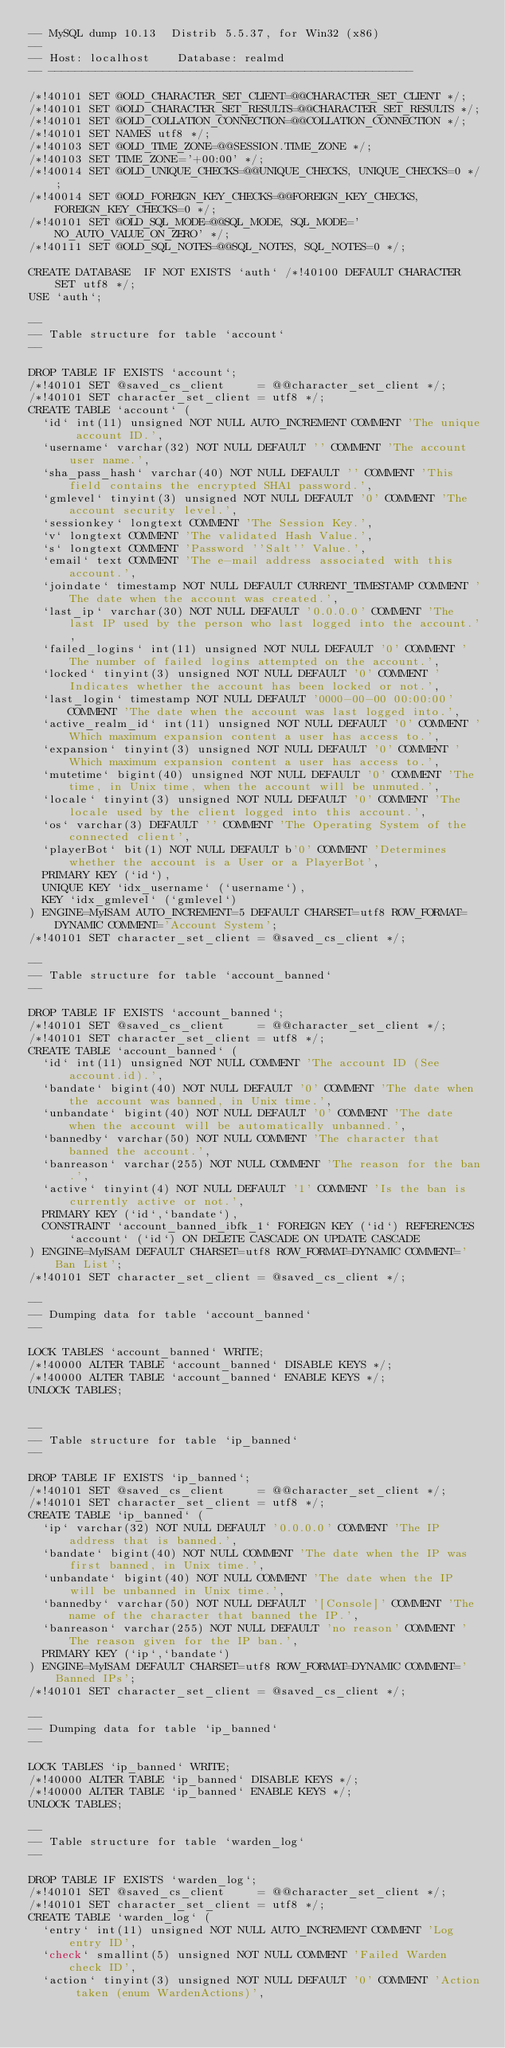<code> <loc_0><loc_0><loc_500><loc_500><_SQL_>-- MySQL dump 10.13  Distrib 5.5.37, for Win32 (x86)
--
-- Host: localhost    Database: realmd
-- ------------------------------------------------------

/*!40101 SET @OLD_CHARACTER_SET_CLIENT=@@CHARACTER_SET_CLIENT */;
/*!40101 SET @OLD_CHARACTER_SET_RESULTS=@@CHARACTER_SET_RESULTS */;
/*!40101 SET @OLD_COLLATION_CONNECTION=@@COLLATION_CONNECTION */;
/*!40101 SET NAMES utf8 */;
/*!40103 SET @OLD_TIME_ZONE=@@SESSION.TIME_ZONE */;
/*!40103 SET TIME_ZONE='+00:00' */;
/*!40014 SET @OLD_UNIQUE_CHECKS=@@UNIQUE_CHECKS, UNIQUE_CHECKS=0 */;
/*!40014 SET @OLD_FOREIGN_KEY_CHECKS=@@FOREIGN_KEY_CHECKS, FOREIGN_KEY_CHECKS=0 */;
/*!40101 SET @OLD_SQL_MODE=@@SQL_MODE, SQL_MODE='NO_AUTO_VALUE_ON_ZERO' */;
/*!40111 SET @OLD_SQL_NOTES=@@SQL_NOTES, SQL_NOTES=0 */;

CREATE DATABASE  IF NOT EXISTS `auth` /*!40100 DEFAULT CHARACTER SET utf8 */;
USE `auth`;

--
-- Table structure for table `account`
--

DROP TABLE IF EXISTS `account`;
/*!40101 SET @saved_cs_client     = @@character_set_client */;
/*!40101 SET character_set_client = utf8 */;
CREATE TABLE `account` (
  `id` int(11) unsigned NOT NULL AUTO_INCREMENT COMMENT 'The unique account ID.',
  `username` varchar(32) NOT NULL DEFAULT '' COMMENT 'The account user name.',
  `sha_pass_hash` varchar(40) NOT NULL DEFAULT '' COMMENT 'This field contains the encrypted SHA1 password.',
  `gmlevel` tinyint(3) unsigned NOT NULL DEFAULT '0' COMMENT 'The account security level.',
  `sessionkey` longtext COMMENT 'The Session Key.',
  `v` longtext COMMENT 'The validated Hash Value.',
  `s` longtext COMMENT 'Password ''Salt'' Value.',
  `email` text COMMENT 'The e-mail address associated with this account.',
  `joindate` timestamp NOT NULL DEFAULT CURRENT_TIMESTAMP COMMENT 'The date when the account was created.',
  `last_ip` varchar(30) NOT NULL DEFAULT '0.0.0.0' COMMENT 'The last IP used by the person who last logged into the account.',
  `failed_logins` int(11) unsigned NOT NULL DEFAULT '0' COMMENT 'The number of failed logins attempted on the account.',
  `locked` tinyint(3) unsigned NOT NULL DEFAULT '0' COMMENT 'Indicates whether the account has been locked or not.',
  `last_login` timestamp NOT NULL DEFAULT '0000-00-00 00:00:00' COMMENT 'The date when the account was last logged into.',
  `active_realm_id` int(11) unsigned NOT NULL DEFAULT '0' COMMENT 'Which maximum expansion content a user has access to.',
  `expansion` tinyint(3) unsigned NOT NULL DEFAULT '0' COMMENT 'Which maximum expansion content a user has access to.',
  `mutetime` bigint(40) unsigned NOT NULL DEFAULT '0' COMMENT 'The time, in Unix time, when the account will be unmuted.',
  `locale` tinyint(3) unsigned NOT NULL DEFAULT '0' COMMENT 'The locale used by the client logged into this account.',
  `os` varchar(3) DEFAULT '' COMMENT 'The Operating System of the connected client',
  `playerBot` bit(1) NOT NULL DEFAULT b'0' COMMENT 'Determines whether the account is a User or a PlayerBot',
  PRIMARY KEY (`id`),
  UNIQUE KEY `idx_username` (`username`),
  KEY `idx_gmlevel` (`gmlevel`)
) ENGINE=MyISAM AUTO_INCREMENT=5 DEFAULT CHARSET=utf8 ROW_FORMAT=DYNAMIC COMMENT='Account System';
/*!40101 SET character_set_client = @saved_cs_client */;

--
-- Table structure for table `account_banned`
--

DROP TABLE IF EXISTS `account_banned`;
/*!40101 SET @saved_cs_client     = @@character_set_client */;
/*!40101 SET character_set_client = utf8 */;
CREATE TABLE `account_banned` (
  `id` int(11) unsigned NOT NULL COMMENT 'The account ID (See account.id).',
  `bandate` bigint(40) NOT NULL DEFAULT '0' COMMENT 'The date when the account was banned, in Unix time.',
  `unbandate` bigint(40) NOT NULL DEFAULT '0' COMMENT 'The date when the account will be automatically unbanned.',
  `bannedby` varchar(50) NOT NULL COMMENT 'The character that banned the account.',
  `banreason` varchar(255) NOT NULL COMMENT 'The reason for the ban.',
  `active` tinyint(4) NOT NULL DEFAULT '1' COMMENT 'Is the ban is currently active or not.',
  PRIMARY KEY (`id`,`bandate`),
  CONSTRAINT `account_banned_ibfk_1` FOREIGN KEY (`id`) REFERENCES `account` (`id`) ON DELETE CASCADE ON UPDATE CASCADE
) ENGINE=MyISAM DEFAULT CHARSET=utf8 ROW_FORMAT=DYNAMIC COMMENT='Ban List';
/*!40101 SET character_set_client = @saved_cs_client */;

--
-- Dumping data for table `account_banned`
--

LOCK TABLES `account_banned` WRITE;
/*!40000 ALTER TABLE `account_banned` DISABLE KEYS */;
/*!40000 ALTER TABLE `account_banned` ENABLE KEYS */;
UNLOCK TABLES;


--
-- Table structure for table `ip_banned`
--

DROP TABLE IF EXISTS `ip_banned`;
/*!40101 SET @saved_cs_client     = @@character_set_client */;
/*!40101 SET character_set_client = utf8 */;
CREATE TABLE `ip_banned` (
  `ip` varchar(32) NOT NULL DEFAULT '0.0.0.0' COMMENT 'The IP address that is banned.',
  `bandate` bigint(40) NOT NULL COMMENT 'The date when the IP was first banned, in Unix time.',
  `unbandate` bigint(40) NOT NULL COMMENT 'The date when the IP will be unbanned in Unix time.',
  `bannedby` varchar(50) NOT NULL DEFAULT '[Console]' COMMENT 'The name of the character that banned the IP.',
  `banreason` varchar(255) NOT NULL DEFAULT 'no reason' COMMENT 'The reason given for the IP ban.',
  PRIMARY KEY (`ip`,`bandate`)
) ENGINE=MyISAM DEFAULT CHARSET=utf8 ROW_FORMAT=DYNAMIC COMMENT='Banned IPs';
/*!40101 SET character_set_client = @saved_cs_client */;

--
-- Dumping data for table `ip_banned`
--

LOCK TABLES `ip_banned` WRITE;
/*!40000 ALTER TABLE `ip_banned` DISABLE KEYS */;
/*!40000 ALTER TABLE `ip_banned` ENABLE KEYS */;
UNLOCK TABLES;

--
-- Table structure for table `warden_log`
--

DROP TABLE IF EXISTS `warden_log`;
/*!40101 SET @saved_cs_client     = @@character_set_client */;
/*!40101 SET character_set_client = utf8 */;
CREATE TABLE `warden_log` (
  `entry` int(11) unsigned NOT NULL AUTO_INCREMENT COMMENT 'Log entry ID',
  `check` smallint(5) unsigned NOT NULL COMMENT 'Failed Warden check ID',
  `action` tinyint(3) unsigned NOT NULL DEFAULT '0' COMMENT 'Action taken (enum WardenActions)',</code> 